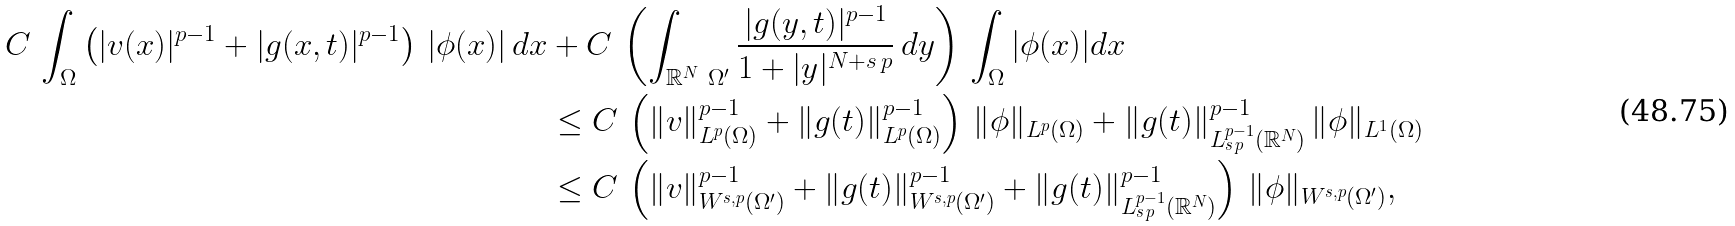<formula> <loc_0><loc_0><loc_500><loc_500>C \, \int _ { \Omega } \left ( | v ( x ) | ^ { p - 1 } + | g ( x , t ) | ^ { p - 1 } \right ) \, | \phi ( x ) | \, d x & + C \, \left ( \int _ { \mathbb { R } ^ { N } \ \Omega ^ { \prime } } \frac { | g ( y , t ) | ^ { p - 1 } } { 1 + | y | ^ { N + s \, p } } \, d y \right ) \, \int _ { \Omega } | \phi ( x ) | d x \\ & \leq C \, \left ( \| v \| _ { L ^ { p } ( \Omega ) } ^ { p - 1 } + \| g ( t ) \| _ { L ^ { p } ( \Omega ) } ^ { p - 1 } \right ) \, \| \phi \| _ { L ^ { p } ( \Omega ) } + \| g ( t ) \| _ { L ^ { p - 1 } _ { s \, p } ( \mathbb { R } ^ { N } ) } ^ { p - 1 } \, \| \phi \| _ { L ^ { 1 } ( \Omega ) } \\ & \leq C \, \left ( \| v \| ^ { p - 1 } _ { W ^ { s , p } ( \Omega ^ { \prime } ) } + \| g ( t ) \| ^ { p - 1 } _ { W ^ { s , p } ( \Omega ^ { \prime } ) } + \| g ( t ) \| _ { L ^ { p - 1 } _ { s \, p } ( \mathbb { R } ^ { N } ) } ^ { p - 1 } \right ) \, \| \phi \| _ { W ^ { s , p } ( \Omega ^ { \prime } ) } ,</formula> 